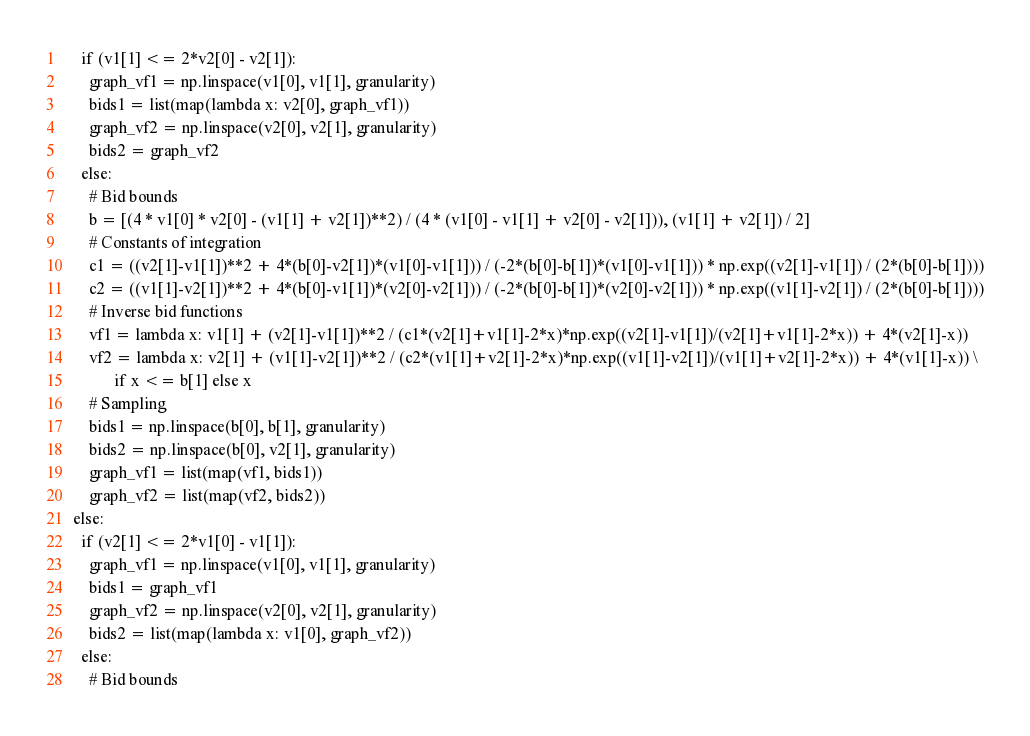<code> <loc_0><loc_0><loc_500><loc_500><_Python_>    if (v1[1] <= 2*v2[0] - v2[1]):
      graph_vf1 = np.linspace(v1[0], v1[1], granularity)
      bids1 = list(map(lambda x: v2[0], graph_vf1))
      graph_vf2 = np.linspace(v2[0], v2[1], granularity)
      bids2 = graph_vf2
    else:
      # Bid bounds
      b = [(4 * v1[0] * v2[0] - (v1[1] + v2[1])**2) / (4 * (v1[0] - v1[1] + v2[0] - v2[1])), (v1[1] + v2[1]) / 2]
      # Constants of integration
      c1 = ((v2[1]-v1[1])**2 + 4*(b[0]-v2[1])*(v1[0]-v1[1])) / (-2*(b[0]-b[1])*(v1[0]-v1[1])) * np.exp((v2[1]-v1[1]) / (2*(b[0]-b[1])))
      c2 = ((v1[1]-v2[1])**2 + 4*(b[0]-v1[1])*(v2[0]-v2[1])) / (-2*(b[0]-b[1])*(v2[0]-v2[1])) * np.exp((v1[1]-v2[1]) / (2*(b[0]-b[1])))
      # Inverse bid functions
      vf1 = lambda x: v1[1] + (v2[1]-v1[1])**2 / (c1*(v2[1]+v1[1]-2*x)*np.exp((v2[1]-v1[1])/(v2[1]+v1[1]-2*x)) + 4*(v2[1]-x))
      vf2 = lambda x: v2[1] + (v1[1]-v2[1])**2 / (c2*(v1[1]+v2[1]-2*x)*np.exp((v1[1]-v2[1])/(v1[1]+v2[1]-2*x)) + 4*(v1[1]-x)) \
            if x <= b[1] else x
      # Sampling
      bids1 = np.linspace(b[0], b[1], granularity)
      bids2 = np.linspace(b[0], v2[1], granularity)
      graph_vf1 = list(map(vf1, bids1))
      graph_vf2 = list(map(vf2, bids2))
  else:
    if (v2[1] <= 2*v1[0] - v1[1]):
      graph_vf1 = np.linspace(v1[0], v1[1], granularity)
      bids1 = graph_vf1
      graph_vf2 = np.linspace(v2[0], v2[1], granularity)
      bids2 = list(map(lambda x: v1[0], graph_vf2))
    else:
      # Bid bounds</code> 